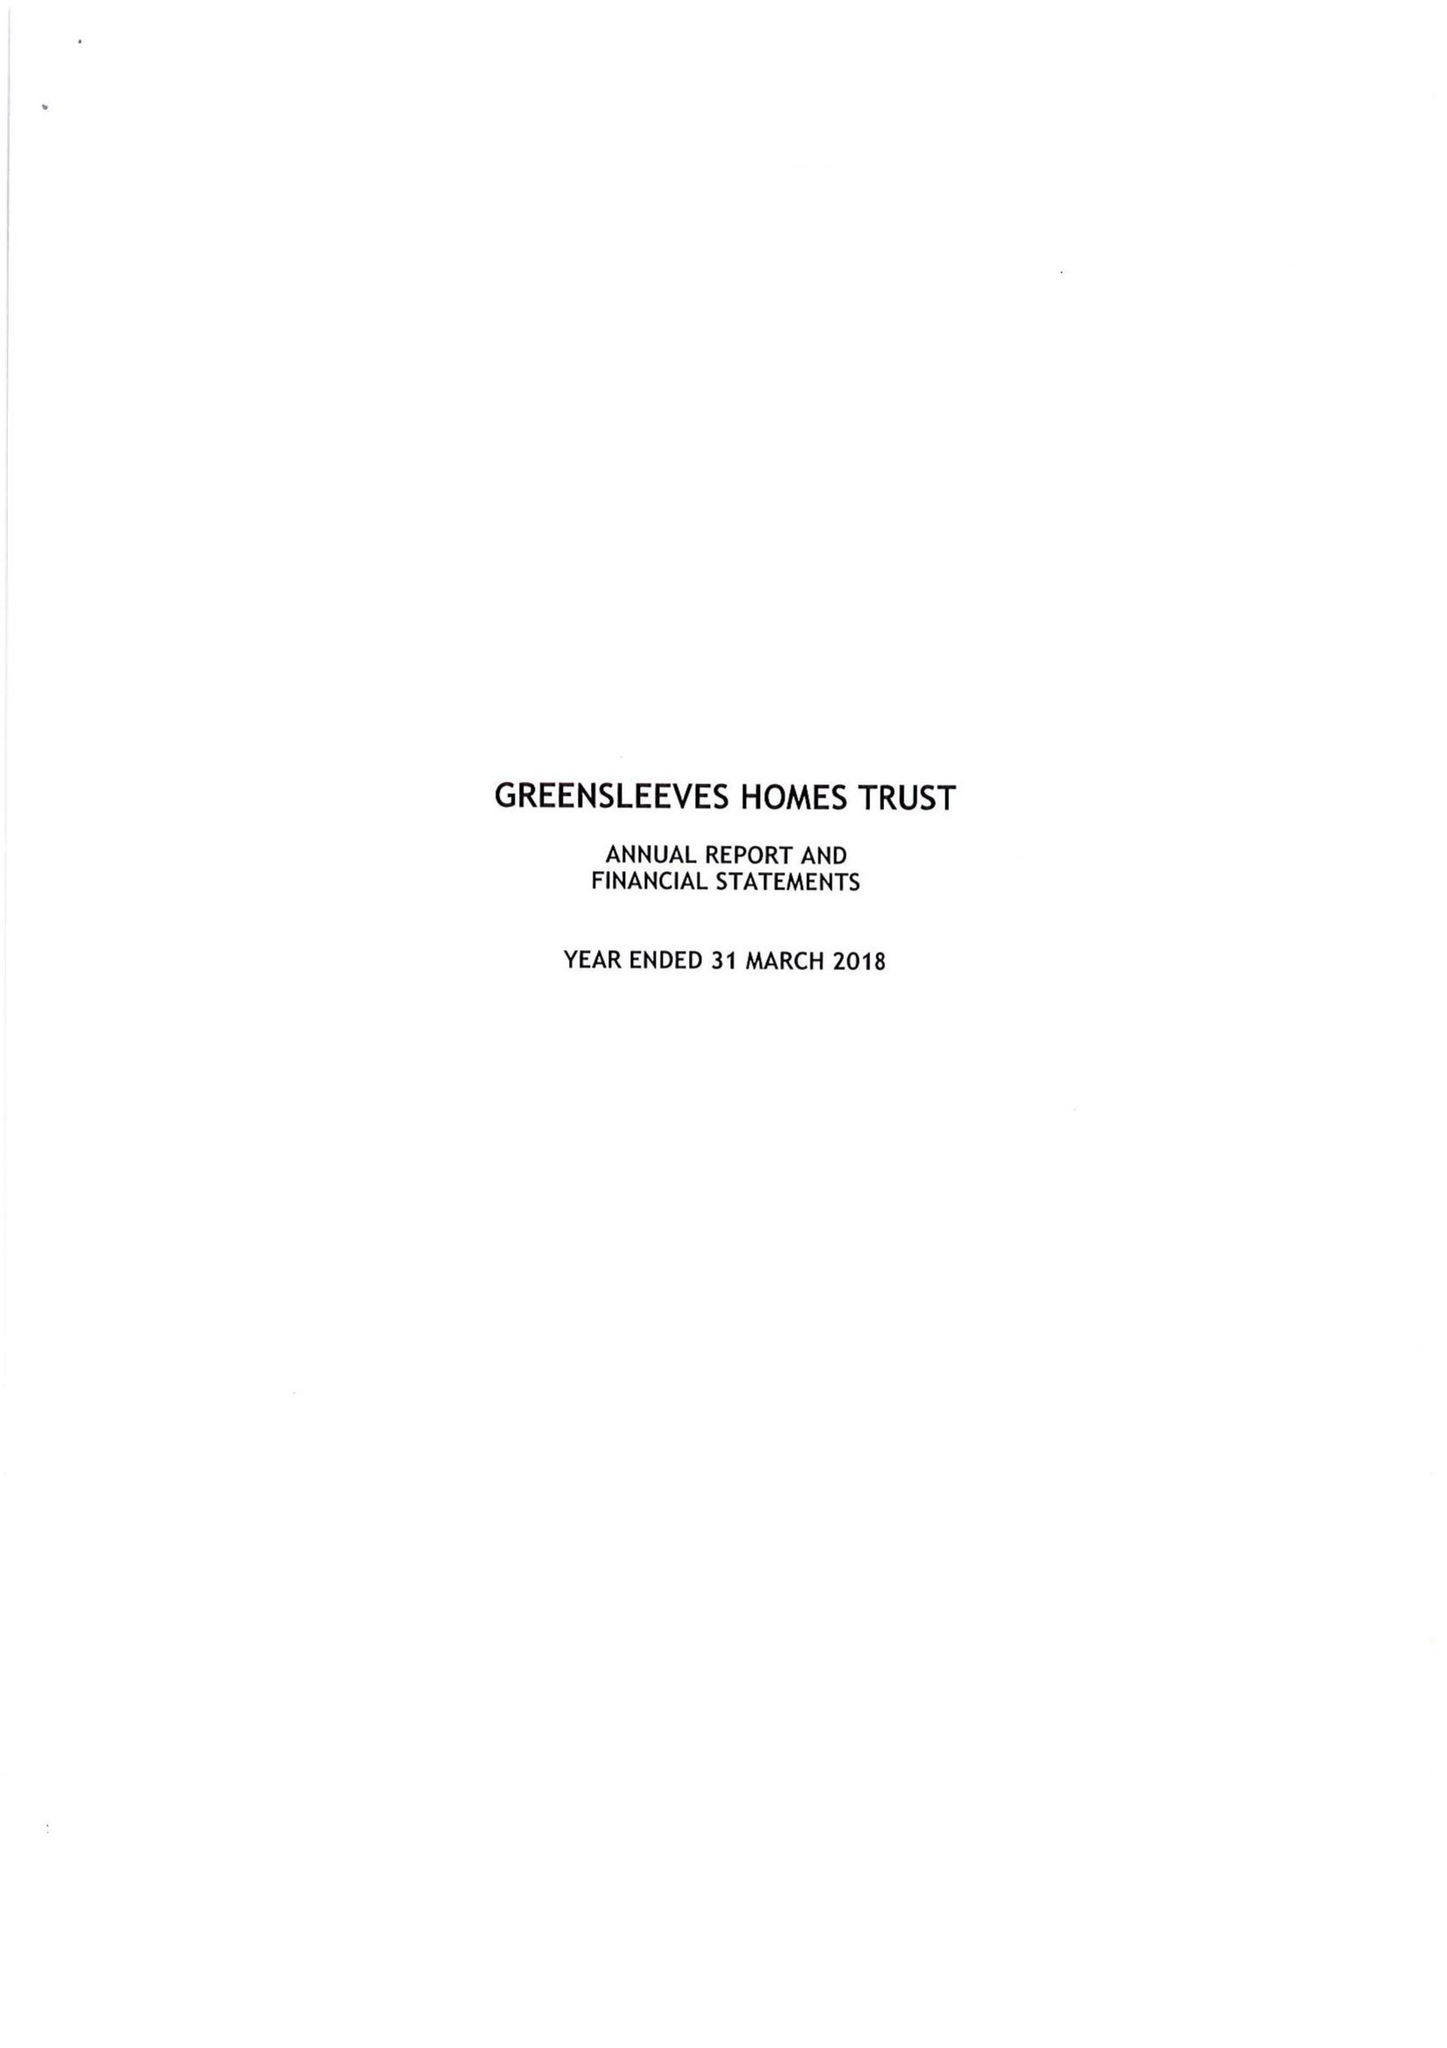What is the value for the charity_name?
Answer the question using a single word or phrase. Greensleeves Homes Trust 